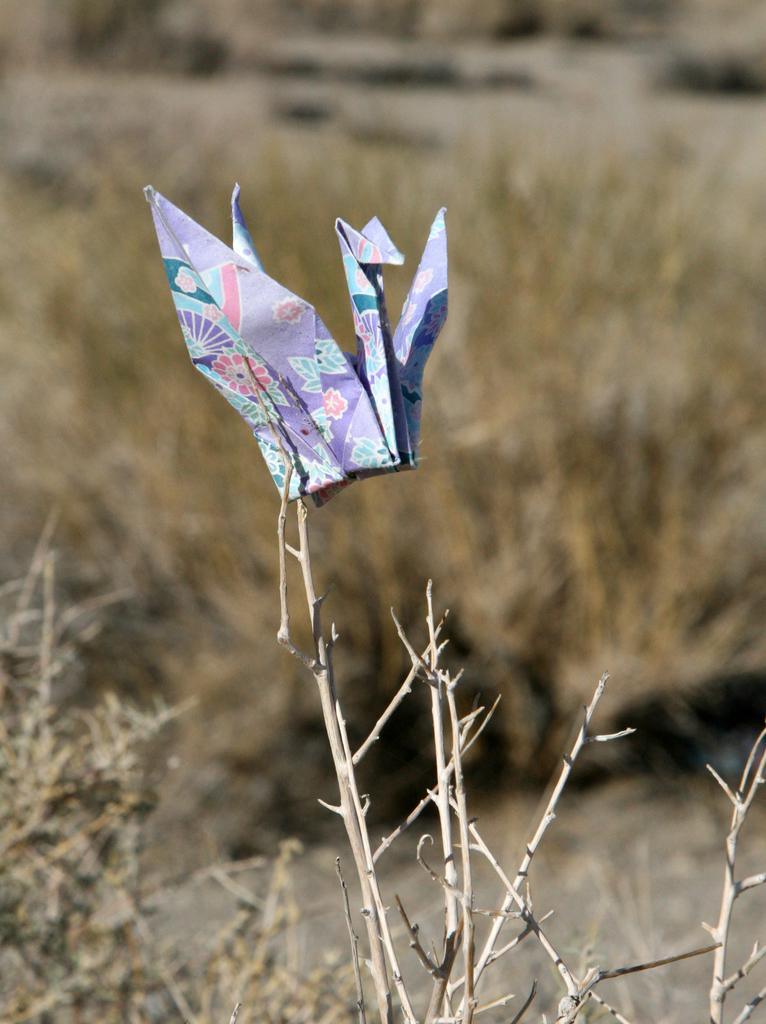What is at the bottom of the image? There is a dried plant at the bottom of the image. What is attached to the dried plant? There is a paper art attached to the dried plant. What can be seen in the background of the image? There are dried plants visible in the background of the image. What type of sleet is falling in the image? There is no mention of sleet in the image. --- Facts: 1. There is a person in the image. 2. The person is wearing a hat. 3. The person is holding a book. 4. The background is a library. Absurd Topics: elephant, piano, dance Conversation: Who or what is in the image? There is a person in the image. What is the person wearing? The person is wearing a hat. What is the person holding? The person is holding a book. Where is the person most likely to be? The background is a library. Reasoning: Let's think step by step in order to produce the conversation. We start by identifying the main subject of the image, which is the person. Next, we describe specific features of the person, such as the hat. Then, we observe the actions of the person, noting that they are holding a book. Finally, we describe the background, which is a library. Absurd Question/Answer: What type of elephant can be seen in the image? There is no mention of an elephant in the image. --- Facts: 1. There is a group of people in the image. 2. The people are wearing matching t-shirts. 3. The people are holding hands. 4. The background is a park. Absurd Topics: car, bicycle, skateboard Conversation: How many people are in the image? There is a group of people in the image. What are the people wearing? The people are wearing matching t-shirts. What are the people doing in the image? The people are holding hands. Where are the people most likely to be? The background is a park. Reasoning: Let's think step by step in order to produce the conversation. We start by identifying the main subject of the image, which is the group of people. Next, we describe specific features of the people, such as the matching t-shirts. Then, we observe the actions of the people, noting that they are holding hands. Finally, we describe the background, which is a park. Absurd Question/Answer: What type of car can be seen in the image? There is no mention of a car in the image. --- Facts: 1. There is a cat in the image. 2. The cat is sitting on a windowsill. 3. The cat is looking out the window. 4. The background is a cityscape. Absurd Topics: dog, horse Conversation: 